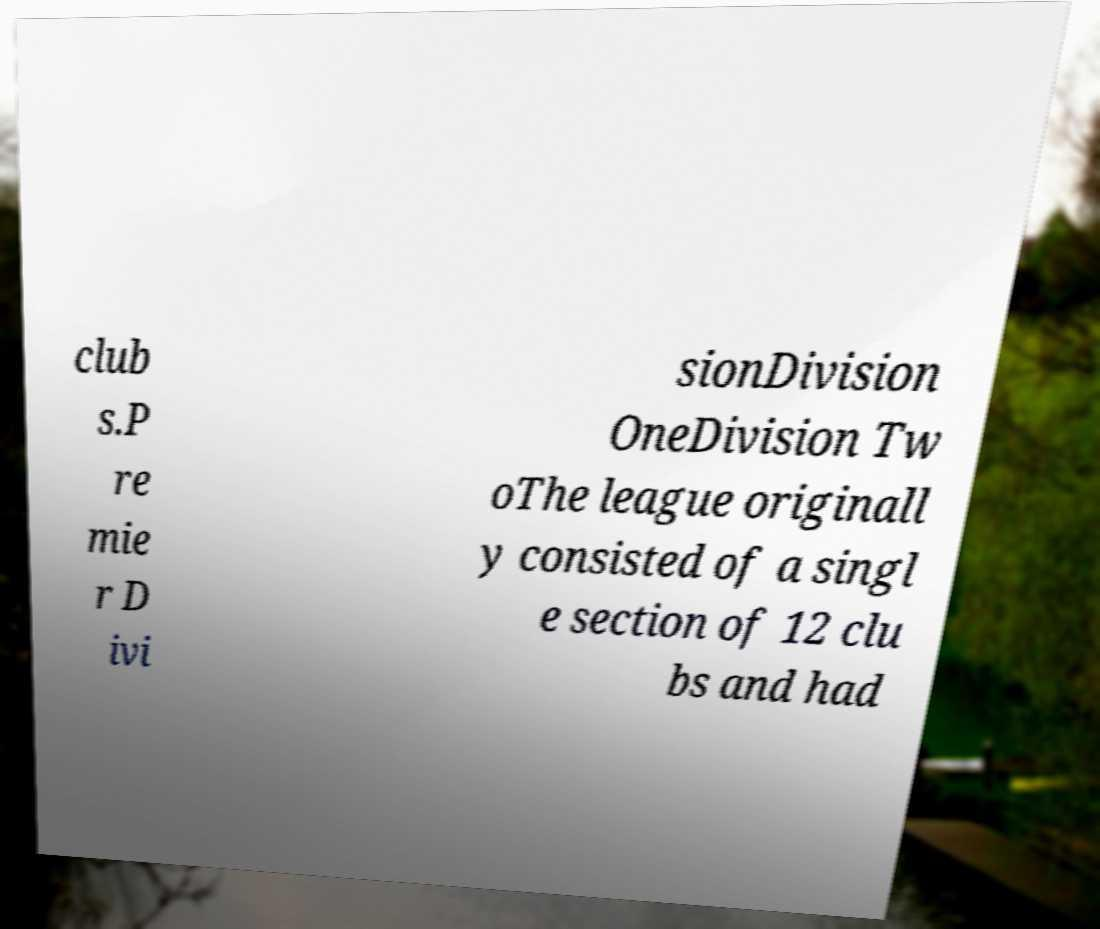There's text embedded in this image that I need extracted. Can you transcribe it verbatim? club s.P re mie r D ivi sionDivision OneDivision Tw oThe league originall y consisted of a singl e section of 12 clu bs and had 